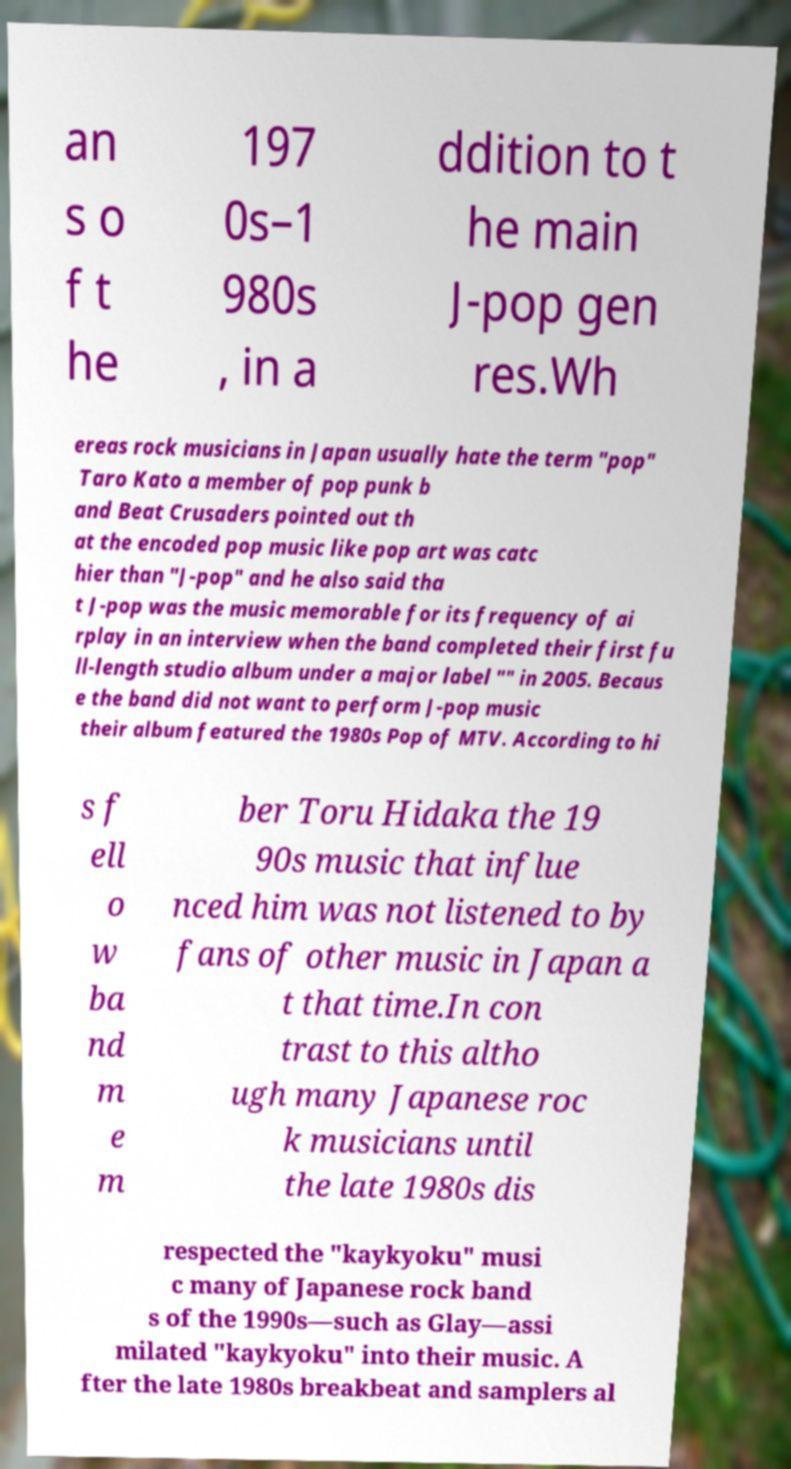For documentation purposes, I need the text within this image transcribed. Could you provide that? an s o f t he 197 0s–1 980s , in a ddition to t he main J-pop gen res.Wh ereas rock musicians in Japan usually hate the term "pop" Taro Kato a member of pop punk b and Beat Crusaders pointed out th at the encoded pop music like pop art was catc hier than "J-pop" and he also said tha t J-pop was the music memorable for its frequency of ai rplay in an interview when the band completed their first fu ll-length studio album under a major label "" in 2005. Becaus e the band did not want to perform J-pop music their album featured the 1980s Pop of MTV. According to hi s f ell o w ba nd m e m ber Toru Hidaka the 19 90s music that influe nced him was not listened to by fans of other music in Japan a t that time.In con trast to this altho ugh many Japanese roc k musicians until the late 1980s dis respected the "kaykyoku" musi c many of Japanese rock band s of the 1990s—such as Glay—assi milated "kaykyoku" into their music. A fter the late 1980s breakbeat and samplers al 